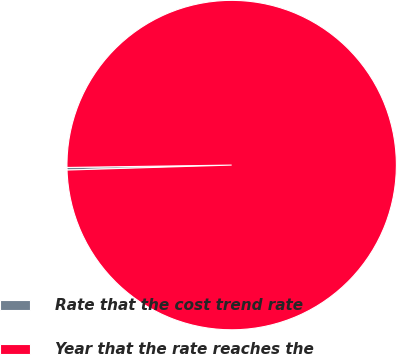Convert chart to OTSL. <chart><loc_0><loc_0><loc_500><loc_500><pie_chart><fcel>Rate that the cost trend rate<fcel>Year that the rate reaches the<nl><fcel>0.25%<fcel>99.75%<nl></chart> 